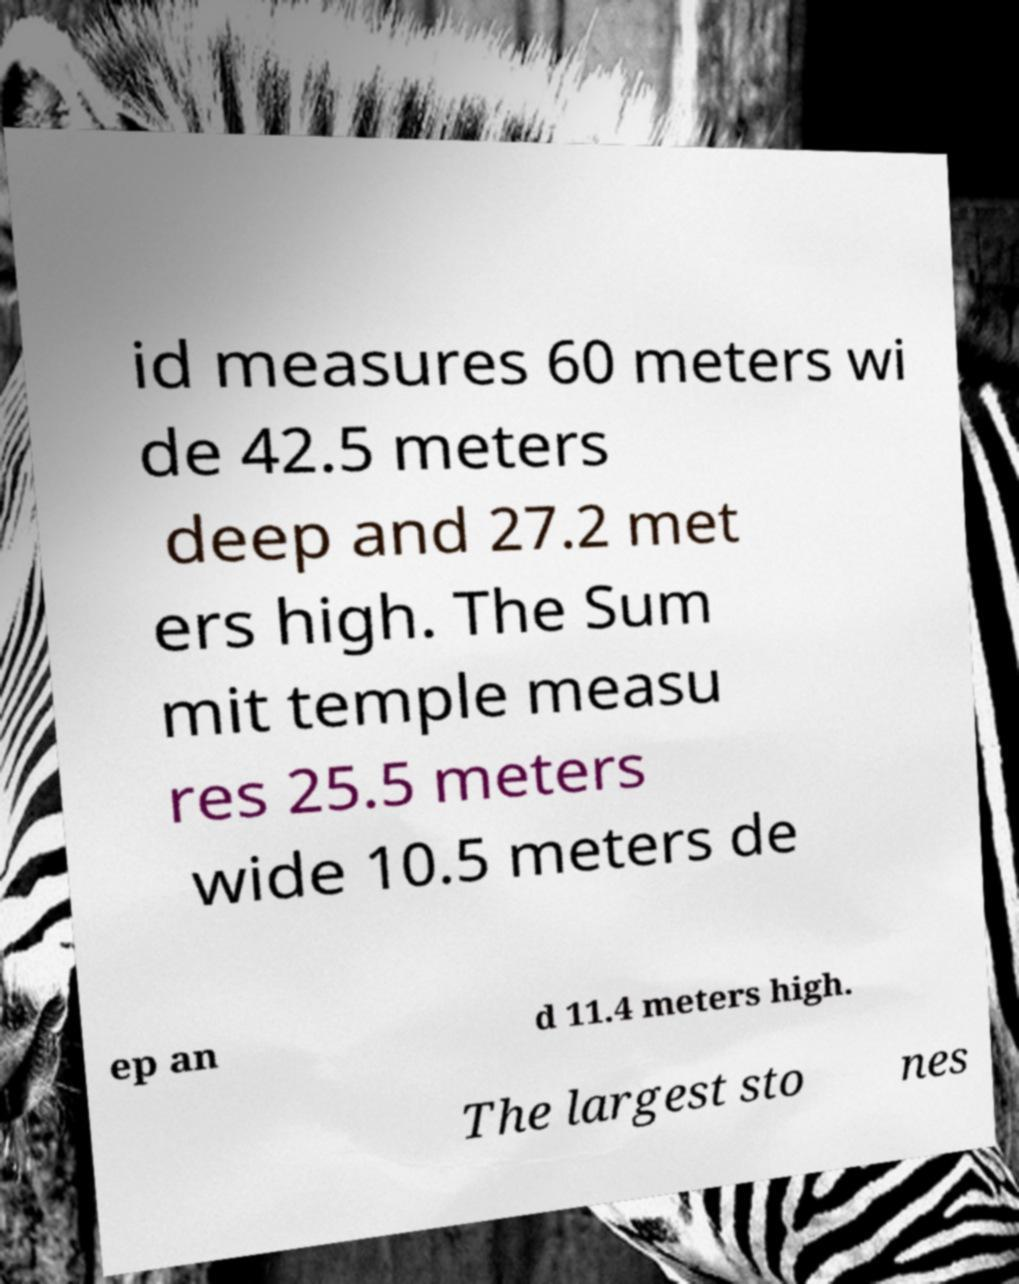I need the written content from this picture converted into text. Can you do that? id measures 60 meters wi de 42.5 meters deep and 27.2 met ers high. The Sum mit temple measu res 25.5 meters wide 10.5 meters de ep an d 11.4 meters high. The largest sto nes 